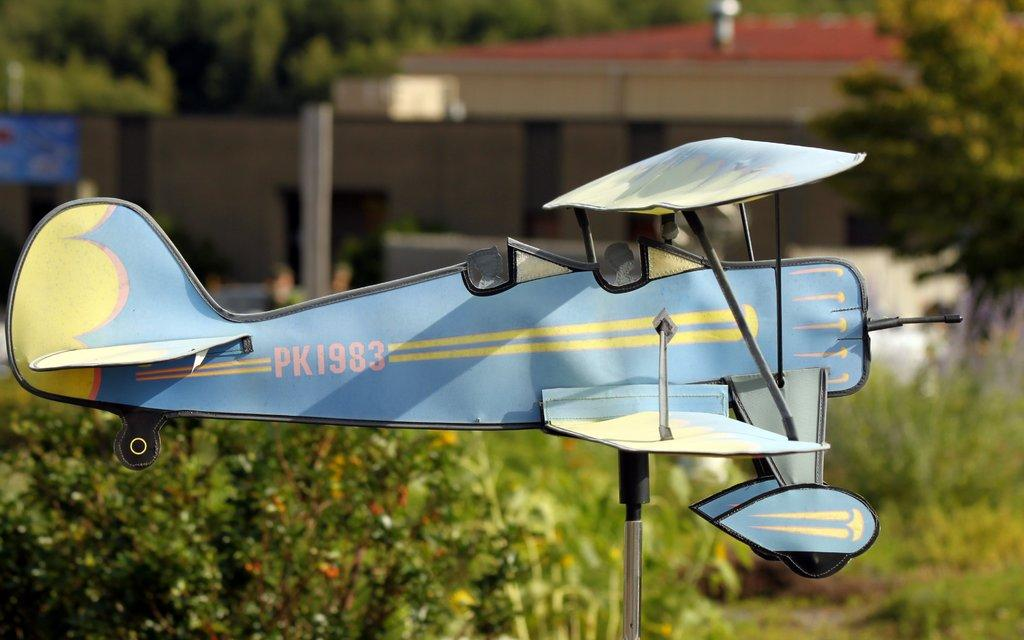<image>
Describe the image concisely. A small blue airplane with the tail sign PK1983. 